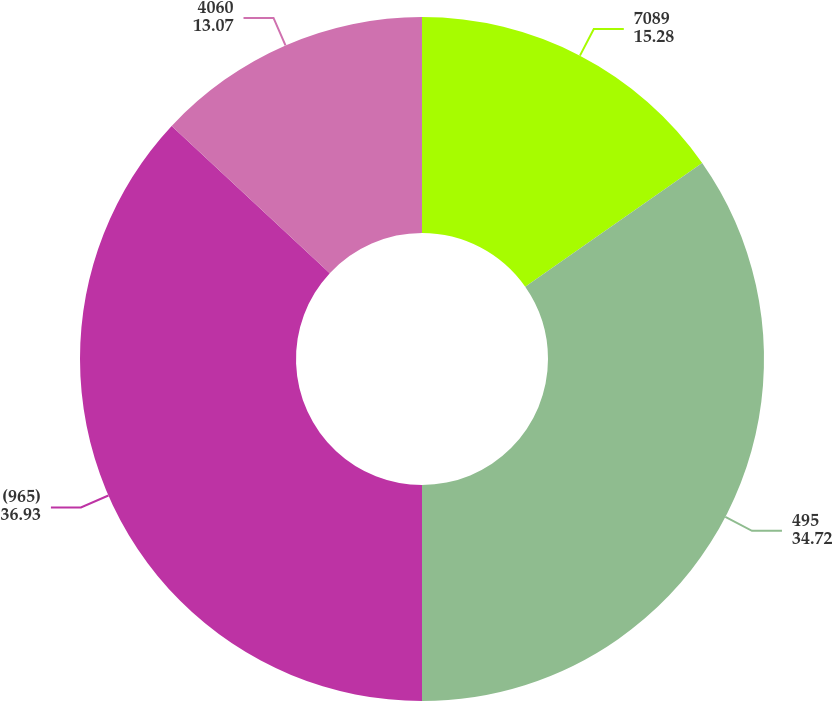Convert chart. <chart><loc_0><loc_0><loc_500><loc_500><pie_chart><fcel>7089<fcel>495<fcel>(965)<fcel>4060<nl><fcel>15.28%<fcel>34.72%<fcel>36.93%<fcel>13.07%<nl></chart> 